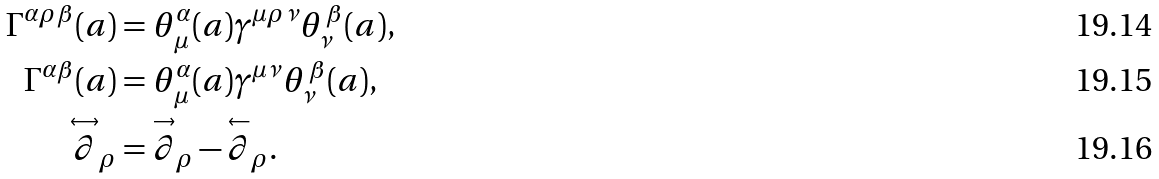<formula> <loc_0><loc_0><loc_500><loc_500>\Gamma ^ { \alpha \rho \beta } ( a ) & = \theta ^ { \alpha } _ { \, \mu } ( a ) \gamma ^ { \mu \rho \nu } \theta _ { \nu } ^ { \, \beta } ( a ) , \\ \Gamma ^ { \alpha \beta } ( a ) & = \theta ^ { \alpha } _ { \, \mu } ( a ) \gamma ^ { \mu \nu } \theta _ { \nu } ^ { \, \beta } ( a ) , \\ \overset { \leftrightarrow } { \partial } _ { \rho } & = \overset { \rightarrow } { \partial } _ { \rho } - \overset { \leftarrow } { \partial } _ { \rho } .</formula> 